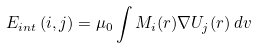<formula> <loc_0><loc_0><loc_500><loc_500>E _ { i n t } \left ( i , j \right ) = \mu _ { 0 } \int M _ { i } ( r ) \nabla U _ { j } ( r ) \, d v</formula> 